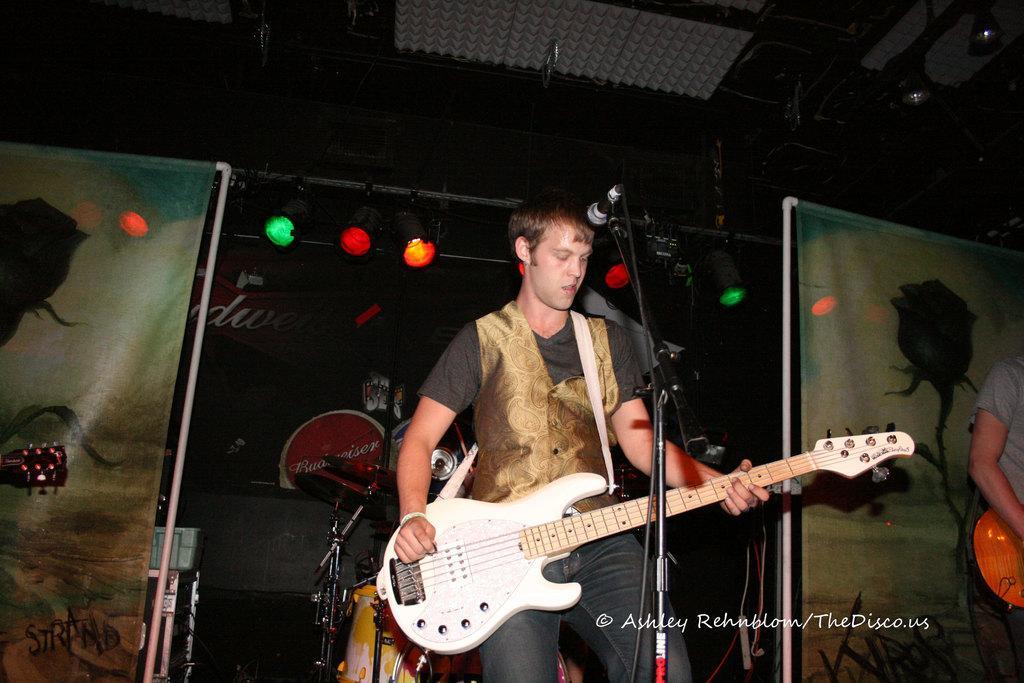In one or two sentences, can you explain what this image depicts? In this image, in the middle there is a boy standing and he is holding a music instrument which is in white color, there is a microphone which is in black color, in the right side there is a person standing and he is holding a object which is in orange, in the background there is a black color poster, there are some lights which are in red, green and orange color. 